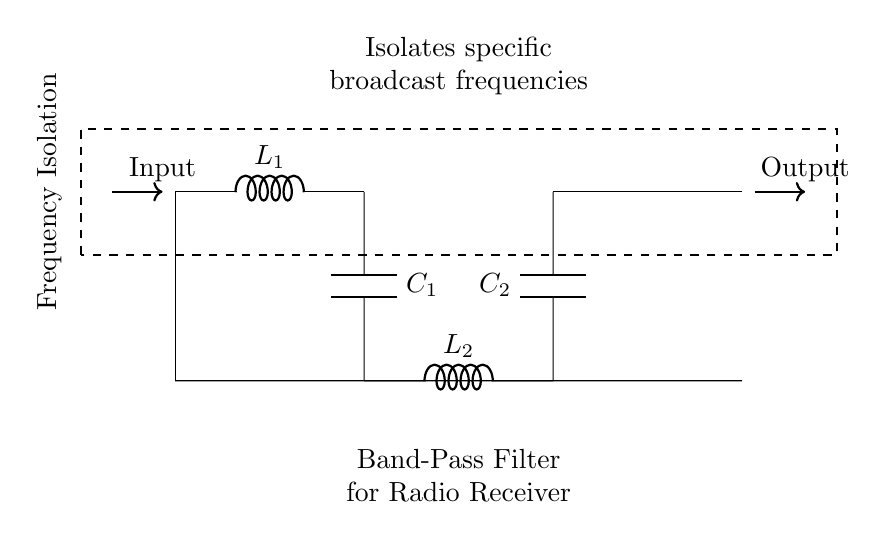What type of filter is represented in the circuit? The circuit diagram specifically shows a band-pass filter, which is designed to allow signals within a certain frequency range to pass while attenuating frequencies outside of that range. This is indicated by the label on the diagram.
Answer: band-pass filter How many inductors are present in the circuit? The circuit diagram contains two inductors labeled L1 and L2, which are components that store energy in a magnetic field when electrical current flows through them. The visual representation confirms this directly.
Answer: 2 What does the label on the diagram indicate about its function? The diagram includes a label that clearly states "Isolates specific broadcast frequencies," indicating the primary function of the band-pass filter is to isolate desired frequencies of radio signals from others.
Answer: isolates specific broadcast frequencies What is the input of the circuit? The circuit's input is clearly marked with an arrow pointing to the left, indicating the direction of incoming signals into the filter. The label 'Input' confirms that this is where the signal enters the circuit.
Answer: Input What components are used in the filter? The circuit diagram includes two inductors (L1 and L2) and two capacitors (C1 and C2), which together form the band-pass filter. Each component plays a critical role in filtering the frequencies.
Answer: inductors and capacitors What is the overall purpose of the components in the circuit? The components work together as part of the band-pass filter to allow certain frequencies to pass through while resisting others, effectively isolating specific broadcast frequencies for clearer signal reception. This is fundamental in radio technology and is explained by the connectivity and arrangement of the components.
Answer: frequency isolation 